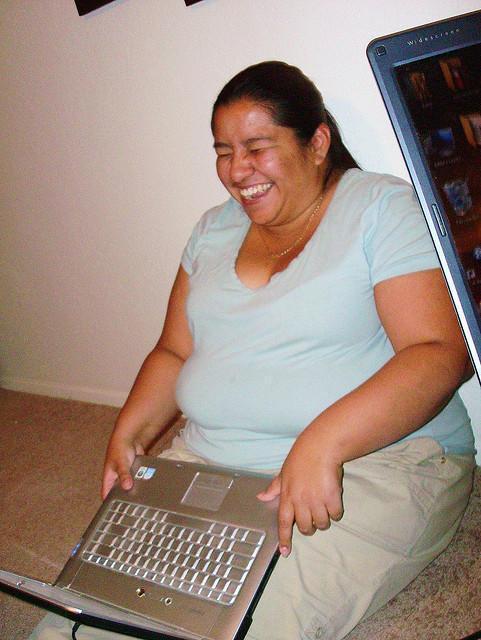How many white surfboards are there?
Give a very brief answer. 0. 